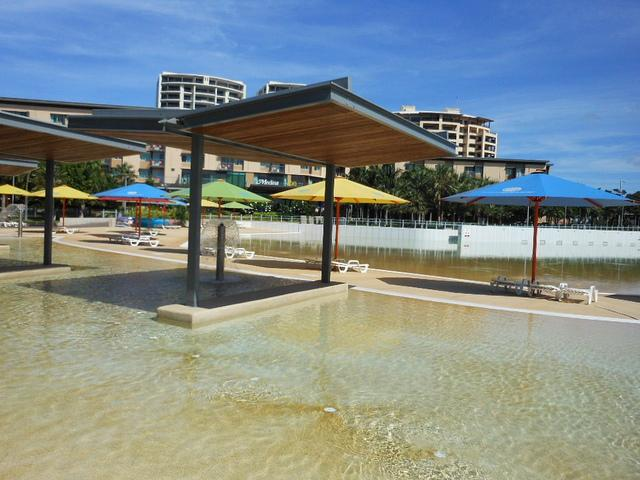This pool is mainly for what swimmers? children 